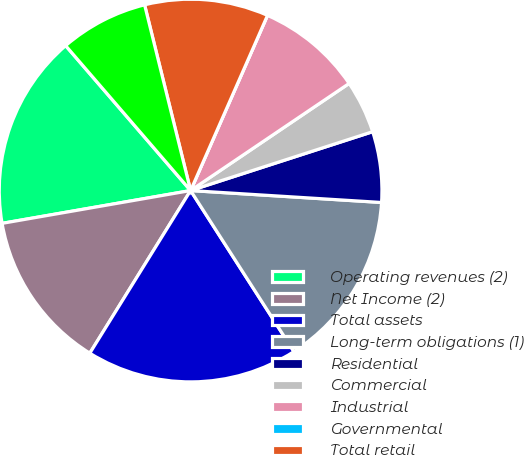Convert chart to OTSL. <chart><loc_0><loc_0><loc_500><loc_500><pie_chart><fcel>Operating revenues (2)<fcel>Net Income (2)<fcel>Total assets<fcel>Long-term obligations (1)<fcel>Residential<fcel>Commercial<fcel>Industrial<fcel>Governmental<fcel>Total retail<fcel>Associated companies<nl><fcel>16.42%<fcel>13.43%<fcel>17.91%<fcel>14.93%<fcel>5.97%<fcel>4.48%<fcel>8.96%<fcel>0.0%<fcel>10.45%<fcel>7.46%<nl></chart> 